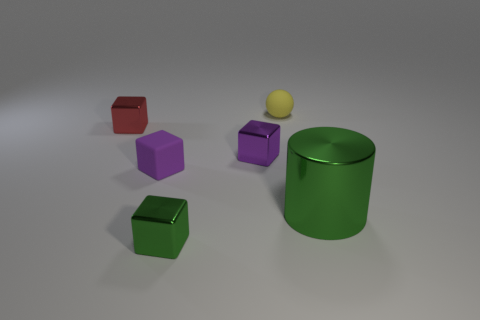Add 1 small yellow matte spheres. How many objects exist? 7 Subtract all spheres. How many objects are left? 5 Add 1 tiny brown cylinders. How many tiny brown cylinders exist? 1 Subtract 1 yellow balls. How many objects are left? 5 Subtract all tiny rubber spheres. Subtract all tiny purple cubes. How many objects are left? 3 Add 3 green blocks. How many green blocks are left? 4 